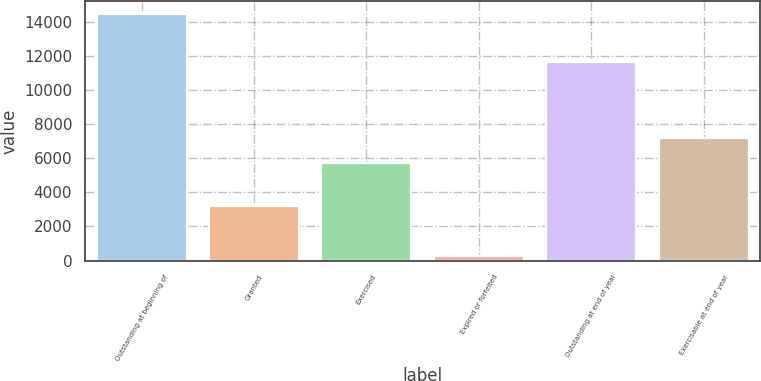<chart> <loc_0><loc_0><loc_500><loc_500><bar_chart><fcel>Outstanding at beginning of<fcel>Granted<fcel>Exercised<fcel>Expired or forfeited<fcel>Outstanding at end of year<fcel>Exercisable at end of year<nl><fcel>14495<fcel>3177<fcel>5753<fcel>268<fcel>11651<fcel>7175.7<nl></chart> 